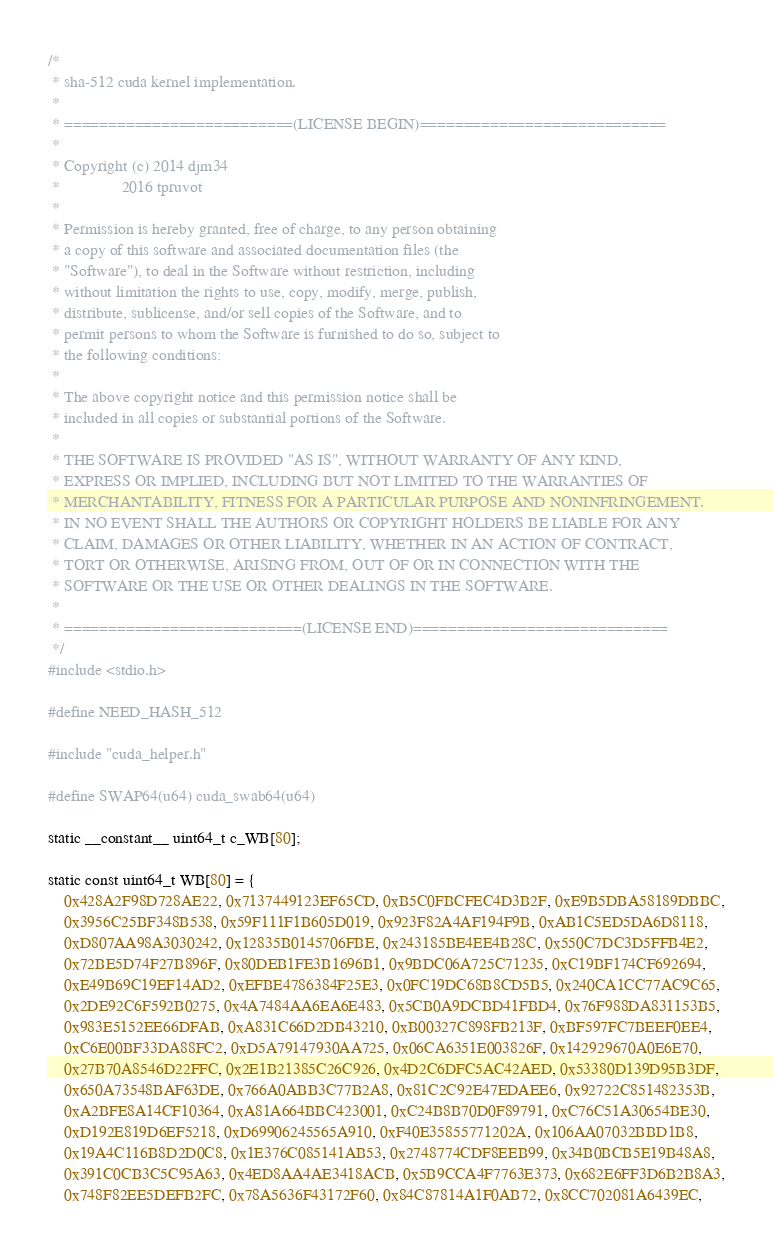Convert code to text. <code><loc_0><loc_0><loc_500><loc_500><_Cuda_>/*
 * sha-512 cuda kernel implementation.
 *
 * ==========================(LICENSE BEGIN)============================
 *
 * Copyright (c) 2014 djm34
 *               2016 tpruvot
 *
 * Permission is hereby granted, free of charge, to any person obtaining
 * a copy of this software and associated documentation files (the
 * "Software"), to deal in the Software without restriction, including
 * without limitation the rights to use, copy, modify, merge, publish,
 * distribute, sublicense, and/or sell copies of the Software, and to
 * permit persons to whom the Software is furnished to do so, subject to
 * the following conditions:
 *
 * The above copyright notice and this permission notice shall be
 * included in all copies or substantial portions of the Software.
 *
 * THE SOFTWARE IS PROVIDED "AS IS", WITHOUT WARRANTY OF ANY KIND,
 * EXPRESS OR IMPLIED, INCLUDING BUT NOT LIMITED TO THE WARRANTIES OF
 * MERCHANTABILITY, FITNESS FOR A PARTICULAR PURPOSE AND NONINFRINGEMENT.
 * IN NO EVENT SHALL THE AUTHORS OR COPYRIGHT HOLDERS BE LIABLE FOR ANY
 * CLAIM, DAMAGES OR OTHER LIABILITY, WHETHER IN AN ACTION OF CONTRACT,
 * TORT OR OTHERWISE, ARISING FROM, OUT OF OR IN CONNECTION WITH THE
 * SOFTWARE OR THE USE OR OTHER DEALINGS IN THE SOFTWARE.
 *
 * ===========================(LICENSE END)=============================
 */
#include <stdio.h>

#define NEED_HASH_512

#include "cuda_helper.h"

#define SWAP64(u64) cuda_swab64(u64)

static __constant__ uint64_t c_WB[80];

static const uint64_t WB[80] = {
	0x428A2F98D728AE22, 0x7137449123EF65CD, 0xB5C0FBCFEC4D3B2F, 0xE9B5DBA58189DBBC,
	0x3956C25BF348B538, 0x59F111F1B605D019, 0x923F82A4AF194F9B, 0xAB1C5ED5DA6D8118,
	0xD807AA98A3030242, 0x12835B0145706FBE, 0x243185BE4EE4B28C, 0x550C7DC3D5FFB4E2,
	0x72BE5D74F27B896F, 0x80DEB1FE3B1696B1, 0x9BDC06A725C71235, 0xC19BF174CF692694,
	0xE49B69C19EF14AD2, 0xEFBE4786384F25E3, 0x0FC19DC68B8CD5B5, 0x240CA1CC77AC9C65,
	0x2DE92C6F592B0275, 0x4A7484AA6EA6E483, 0x5CB0A9DCBD41FBD4, 0x76F988DA831153B5,
	0x983E5152EE66DFAB, 0xA831C66D2DB43210, 0xB00327C898FB213F, 0xBF597FC7BEEF0EE4,
	0xC6E00BF33DA88FC2, 0xD5A79147930AA725, 0x06CA6351E003826F, 0x142929670A0E6E70,
	0x27B70A8546D22FFC, 0x2E1B21385C26C926, 0x4D2C6DFC5AC42AED, 0x53380D139D95B3DF,
	0x650A73548BAF63DE, 0x766A0ABB3C77B2A8, 0x81C2C92E47EDAEE6, 0x92722C851482353B,
	0xA2BFE8A14CF10364, 0xA81A664BBC423001, 0xC24B8B70D0F89791, 0xC76C51A30654BE30,
	0xD192E819D6EF5218, 0xD69906245565A910, 0xF40E35855771202A, 0x106AA07032BBD1B8,
	0x19A4C116B8D2D0C8, 0x1E376C085141AB53, 0x2748774CDF8EEB99, 0x34B0BCB5E19B48A8,
	0x391C0CB3C5C95A63, 0x4ED8AA4AE3418ACB, 0x5B9CCA4F7763E373, 0x682E6FF3D6B2B8A3,
	0x748F82EE5DEFB2FC, 0x78A5636F43172F60, 0x84C87814A1F0AB72, 0x8CC702081A6439EC,</code> 